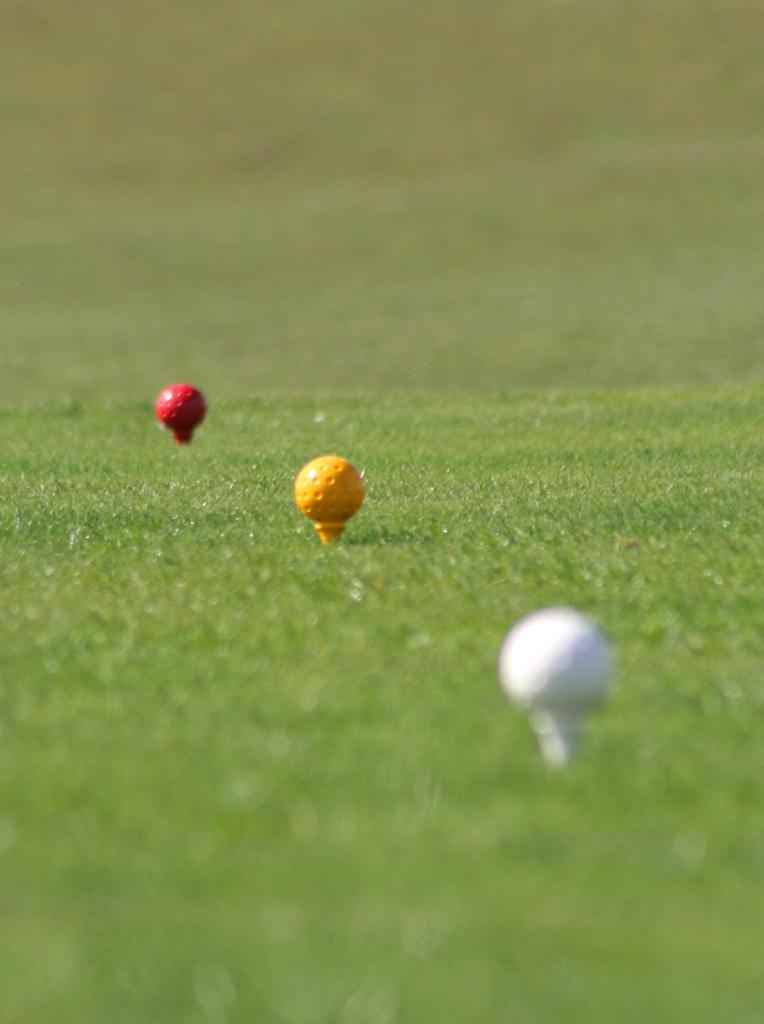What type of surface is visible in the image? There is a ground in the image. What is the color of the grass on the ground? The grass on the ground is green. How many balls are on the ground in the image? There are three balls on the ground. What colors are the balls? One ball is white, one ball is yellow, and one ball is red. What is the chance of finding a rock in the image? There is no mention of a rock in the image, so it is impossible to determine the chance of finding one. 